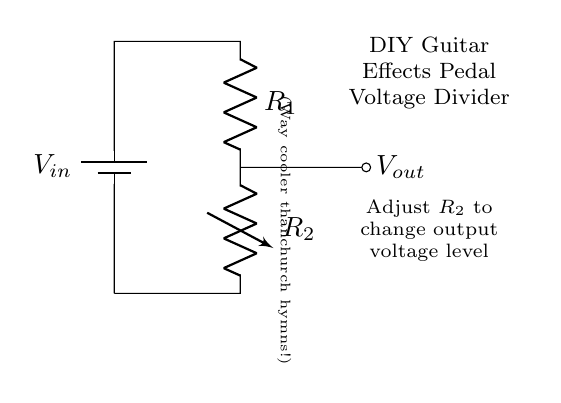What is the input voltage of this circuit? The input voltage, labeled as \( V_{in} \), is represented at the battery. The actual value isn’t specified in the circuit but it is the source voltage for the divider.
Answer: \( V_{in} \) What are the components used in this circuit? The components can be identified from the diagram; there is a battery, a resistor labeled \( R_1 \), and a variable resistor labeled \( R_2 \). These are standard components in a voltage divider configuration.
Answer: Battery, \( R_1 \), \( R_2 \) What does \( V_{out} \) represent in the circuit? \( V_{out} \) is the output voltage taken across \( R_1 \), which varies based on the resistance value of \( R_2 \) in the circuit. It is crucial for determining the voltage level delivered to the effects pedal.
Answer: Output voltage How does changing \( R_2 \) affect \( V_{out} \)? Changing \( R_2 \) alters the resistance ratio between \( R_1 \) and \( R_2 \), thus modifying the voltage division according to the formula. Reducing \( R_2 \) increases \( V_{out} \), and vice versa, allowing for variable voltage levels.
Answer: It changes \( V_{out} \) What type of circuit is shown here? The circuit displayed is a voltage divider, commonly used to create adjustable voltage levels. It adjusts any input voltage to a desired output voltage while maintaining simplicity and effectiveness.
Answer: Voltage divider What does the note about "way cooler than church hymns" imply about the circuit's use? The note highlights the playful nature of the project, suggesting that the circuit's purpose is for a DIY guitar effects pedal, intended for creative sound modification rather than traditional or religious contexts.
Answer: It’s for music effects 